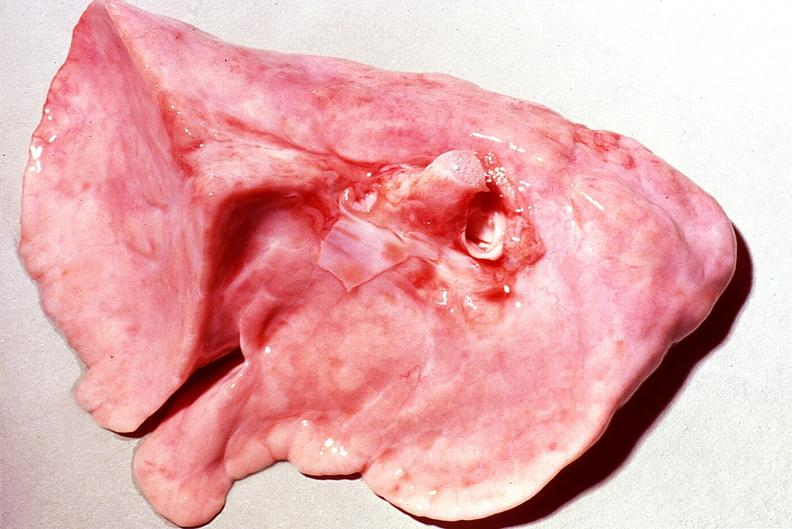where is this?
Answer the question using a single word or phrase. Lung 